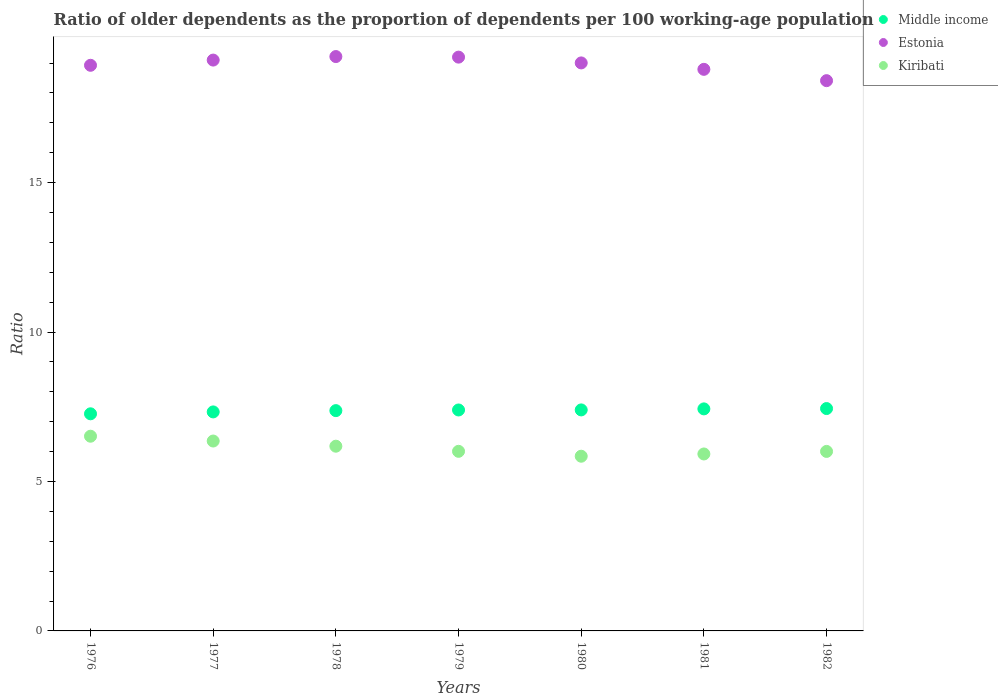What is the age dependency ratio(old) in Middle income in 1982?
Give a very brief answer. 7.44. Across all years, what is the maximum age dependency ratio(old) in Middle income?
Give a very brief answer. 7.44. Across all years, what is the minimum age dependency ratio(old) in Middle income?
Keep it short and to the point. 7.26. In which year was the age dependency ratio(old) in Middle income maximum?
Offer a very short reply. 1982. In which year was the age dependency ratio(old) in Middle income minimum?
Provide a succinct answer. 1976. What is the total age dependency ratio(old) in Estonia in the graph?
Offer a terse response. 132.65. What is the difference between the age dependency ratio(old) in Kiribati in 1978 and that in 1981?
Provide a succinct answer. 0.26. What is the difference between the age dependency ratio(old) in Estonia in 1979 and the age dependency ratio(old) in Kiribati in 1978?
Provide a short and direct response. 13.02. What is the average age dependency ratio(old) in Estonia per year?
Make the answer very short. 18.95. In the year 1978, what is the difference between the age dependency ratio(old) in Estonia and age dependency ratio(old) in Kiribati?
Offer a terse response. 13.04. In how many years, is the age dependency ratio(old) in Estonia greater than 16?
Your answer should be compact. 7. What is the ratio of the age dependency ratio(old) in Kiribati in 1977 to that in 1980?
Keep it short and to the point. 1.09. What is the difference between the highest and the second highest age dependency ratio(old) in Estonia?
Make the answer very short. 0.02. What is the difference between the highest and the lowest age dependency ratio(old) in Estonia?
Your response must be concise. 0.81. Is it the case that in every year, the sum of the age dependency ratio(old) in Estonia and age dependency ratio(old) in Middle income  is greater than the age dependency ratio(old) in Kiribati?
Ensure brevity in your answer.  Yes. Is the age dependency ratio(old) in Kiribati strictly greater than the age dependency ratio(old) in Middle income over the years?
Your answer should be very brief. No. How many dotlines are there?
Make the answer very short. 3. How many years are there in the graph?
Provide a short and direct response. 7. What is the difference between two consecutive major ticks on the Y-axis?
Ensure brevity in your answer.  5. Does the graph contain grids?
Keep it short and to the point. No. Where does the legend appear in the graph?
Your answer should be compact. Top right. How many legend labels are there?
Provide a succinct answer. 3. What is the title of the graph?
Your answer should be very brief. Ratio of older dependents as the proportion of dependents per 100 working-age population. Does "St. Kitts and Nevis" appear as one of the legend labels in the graph?
Offer a very short reply. No. What is the label or title of the Y-axis?
Keep it short and to the point. Ratio. What is the Ratio of Middle income in 1976?
Ensure brevity in your answer.  7.26. What is the Ratio in Estonia in 1976?
Offer a very short reply. 18.93. What is the Ratio of Kiribati in 1976?
Ensure brevity in your answer.  6.51. What is the Ratio in Middle income in 1977?
Make the answer very short. 7.33. What is the Ratio in Estonia in 1977?
Ensure brevity in your answer.  19.1. What is the Ratio of Kiribati in 1977?
Your response must be concise. 6.35. What is the Ratio of Middle income in 1978?
Give a very brief answer. 7.37. What is the Ratio in Estonia in 1978?
Make the answer very short. 19.22. What is the Ratio of Kiribati in 1978?
Make the answer very short. 6.18. What is the Ratio of Middle income in 1979?
Your answer should be compact. 7.39. What is the Ratio of Estonia in 1979?
Your answer should be very brief. 19.2. What is the Ratio in Kiribati in 1979?
Provide a succinct answer. 6.01. What is the Ratio of Middle income in 1980?
Your response must be concise. 7.39. What is the Ratio in Estonia in 1980?
Ensure brevity in your answer.  19. What is the Ratio in Kiribati in 1980?
Your answer should be compact. 5.85. What is the Ratio of Middle income in 1981?
Your answer should be very brief. 7.43. What is the Ratio of Estonia in 1981?
Your answer should be compact. 18.79. What is the Ratio in Kiribati in 1981?
Offer a terse response. 5.92. What is the Ratio of Middle income in 1982?
Give a very brief answer. 7.44. What is the Ratio of Estonia in 1982?
Offer a terse response. 18.41. What is the Ratio of Kiribati in 1982?
Provide a succinct answer. 6.01. Across all years, what is the maximum Ratio in Middle income?
Keep it short and to the point. 7.44. Across all years, what is the maximum Ratio in Estonia?
Your answer should be compact. 19.22. Across all years, what is the maximum Ratio in Kiribati?
Offer a very short reply. 6.51. Across all years, what is the minimum Ratio in Middle income?
Keep it short and to the point. 7.26. Across all years, what is the minimum Ratio of Estonia?
Your answer should be very brief. 18.41. Across all years, what is the minimum Ratio in Kiribati?
Provide a short and direct response. 5.85. What is the total Ratio in Middle income in the graph?
Provide a short and direct response. 51.62. What is the total Ratio of Estonia in the graph?
Provide a short and direct response. 132.65. What is the total Ratio in Kiribati in the graph?
Make the answer very short. 42.83. What is the difference between the Ratio in Middle income in 1976 and that in 1977?
Offer a terse response. -0.06. What is the difference between the Ratio of Estonia in 1976 and that in 1977?
Make the answer very short. -0.17. What is the difference between the Ratio of Kiribati in 1976 and that in 1977?
Provide a short and direct response. 0.16. What is the difference between the Ratio in Middle income in 1976 and that in 1978?
Ensure brevity in your answer.  -0.11. What is the difference between the Ratio in Estonia in 1976 and that in 1978?
Your answer should be very brief. -0.29. What is the difference between the Ratio in Kiribati in 1976 and that in 1978?
Offer a very short reply. 0.33. What is the difference between the Ratio in Middle income in 1976 and that in 1979?
Offer a very short reply. -0.13. What is the difference between the Ratio in Estonia in 1976 and that in 1979?
Your response must be concise. -0.27. What is the difference between the Ratio in Kiribati in 1976 and that in 1979?
Provide a short and direct response. 0.51. What is the difference between the Ratio in Middle income in 1976 and that in 1980?
Your answer should be very brief. -0.13. What is the difference between the Ratio of Estonia in 1976 and that in 1980?
Offer a terse response. -0.08. What is the difference between the Ratio in Kiribati in 1976 and that in 1980?
Your answer should be compact. 0.67. What is the difference between the Ratio in Middle income in 1976 and that in 1981?
Provide a short and direct response. -0.16. What is the difference between the Ratio in Estonia in 1976 and that in 1981?
Ensure brevity in your answer.  0.14. What is the difference between the Ratio of Kiribati in 1976 and that in 1981?
Your answer should be very brief. 0.59. What is the difference between the Ratio in Middle income in 1976 and that in 1982?
Your answer should be compact. -0.18. What is the difference between the Ratio of Estonia in 1976 and that in 1982?
Offer a very short reply. 0.51. What is the difference between the Ratio in Kiribati in 1976 and that in 1982?
Provide a succinct answer. 0.51. What is the difference between the Ratio of Middle income in 1977 and that in 1978?
Keep it short and to the point. -0.04. What is the difference between the Ratio in Estonia in 1977 and that in 1978?
Keep it short and to the point. -0.12. What is the difference between the Ratio in Kiribati in 1977 and that in 1978?
Offer a terse response. 0.17. What is the difference between the Ratio of Middle income in 1977 and that in 1979?
Provide a succinct answer. -0.07. What is the difference between the Ratio in Estonia in 1977 and that in 1979?
Your response must be concise. -0.1. What is the difference between the Ratio in Kiribati in 1977 and that in 1979?
Your answer should be compact. 0.34. What is the difference between the Ratio in Middle income in 1977 and that in 1980?
Give a very brief answer. -0.07. What is the difference between the Ratio in Estonia in 1977 and that in 1980?
Make the answer very short. 0.1. What is the difference between the Ratio of Kiribati in 1977 and that in 1980?
Ensure brevity in your answer.  0.51. What is the difference between the Ratio of Middle income in 1977 and that in 1981?
Your answer should be compact. -0.1. What is the difference between the Ratio in Estonia in 1977 and that in 1981?
Make the answer very short. 0.31. What is the difference between the Ratio of Kiribati in 1977 and that in 1981?
Your response must be concise. 0.43. What is the difference between the Ratio in Middle income in 1977 and that in 1982?
Your answer should be very brief. -0.11. What is the difference between the Ratio in Estonia in 1977 and that in 1982?
Ensure brevity in your answer.  0.69. What is the difference between the Ratio of Kiribati in 1977 and that in 1982?
Keep it short and to the point. 0.35. What is the difference between the Ratio in Middle income in 1978 and that in 1979?
Give a very brief answer. -0.02. What is the difference between the Ratio in Estonia in 1978 and that in 1979?
Offer a terse response. 0.02. What is the difference between the Ratio of Kiribati in 1978 and that in 1979?
Keep it short and to the point. 0.17. What is the difference between the Ratio in Middle income in 1978 and that in 1980?
Keep it short and to the point. -0.02. What is the difference between the Ratio in Estonia in 1978 and that in 1980?
Your response must be concise. 0.21. What is the difference between the Ratio of Kiribati in 1978 and that in 1980?
Your response must be concise. 0.34. What is the difference between the Ratio of Middle income in 1978 and that in 1981?
Offer a terse response. -0.06. What is the difference between the Ratio of Estonia in 1978 and that in 1981?
Provide a succinct answer. 0.43. What is the difference between the Ratio of Kiribati in 1978 and that in 1981?
Give a very brief answer. 0.26. What is the difference between the Ratio of Middle income in 1978 and that in 1982?
Make the answer very short. -0.07. What is the difference between the Ratio of Estonia in 1978 and that in 1982?
Provide a succinct answer. 0.81. What is the difference between the Ratio of Kiribati in 1978 and that in 1982?
Provide a short and direct response. 0.17. What is the difference between the Ratio of Middle income in 1979 and that in 1980?
Ensure brevity in your answer.  -0. What is the difference between the Ratio of Estonia in 1979 and that in 1980?
Keep it short and to the point. 0.19. What is the difference between the Ratio in Kiribati in 1979 and that in 1980?
Your answer should be compact. 0.16. What is the difference between the Ratio in Middle income in 1979 and that in 1981?
Ensure brevity in your answer.  -0.04. What is the difference between the Ratio in Estonia in 1979 and that in 1981?
Give a very brief answer. 0.41. What is the difference between the Ratio in Kiribati in 1979 and that in 1981?
Your response must be concise. 0.09. What is the difference between the Ratio of Middle income in 1979 and that in 1982?
Provide a succinct answer. -0.05. What is the difference between the Ratio in Estonia in 1979 and that in 1982?
Give a very brief answer. 0.79. What is the difference between the Ratio of Kiribati in 1979 and that in 1982?
Give a very brief answer. 0. What is the difference between the Ratio in Middle income in 1980 and that in 1981?
Ensure brevity in your answer.  -0.03. What is the difference between the Ratio of Estonia in 1980 and that in 1981?
Give a very brief answer. 0.21. What is the difference between the Ratio in Kiribati in 1980 and that in 1981?
Your answer should be very brief. -0.08. What is the difference between the Ratio in Middle income in 1980 and that in 1982?
Provide a short and direct response. -0.05. What is the difference between the Ratio in Estonia in 1980 and that in 1982?
Provide a succinct answer. 0.59. What is the difference between the Ratio of Kiribati in 1980 and that in 1982?
Make the answer very short. -0.16. What is the difference between the Ratio of Middle income in 1981 and that in 1982?
Offer a terse response. -0.01. What is the difference between the Ratio in Estonia in 1981 and that in 1982?
Provide a succinct answer. 0.38. What is the difference between the Ratio of Kiribati in 1981 and that in 1982?
Your response must be concise. -0.09. What is the difference between the Ratio of Middle income in 1976 and the Ratio of Estonia in 1977?
Make the answer very short. -11.84. What is the difference between the Ratio of Middle income in 1976 and the Ratio of Kiribati in 1977?
Provide a succinct answer. 0.91. What is the difference between the Ratio in Estonia in 1976 and the Ratio in Kiribati in 1977?
Provide a succinct answer. 12.57. What is the difference between the Ratio of Middle income in 1976 and the Ratio of Estonia in 1978?
Offer a very short reply. -11.95. What is the difference between the Ratio of Middle income in 1976 and the Ratio of Kiribati in 1978?
Offer a terse response. 1.08. What is the difference between the Ratio of Estonia in 1976 and the Ratio of Kiribati in 1978?
Give a very brief answer. 12.74. What is the difference between the Ratio of Middle income in 1976 and the Ratio of Estonia in 1979?
Provide a succinct answer. -11.93. What is the difference between the Ratio in Middle income in 1976 and the Ratio in Kiribati in 1979?
Provide a short and direct response. 1.26. What is the difference between the Ratio of Estonia in 1976 and the Ratio of Kiribati in 1979?
Provide a succinct answer. 12.92. What is the difference between the Ratio in Middle income in 1976 and the Ratio in Estonia in 1980?
Provide a succinct answer. -11.74. What is the difference between the Ratio of Middle income in 1976 and the Ratio of Kiribati in 1980?
Offer a very short reply. 1.42. What is the difference between the Ratio in Estonia in 1976 and the Ratio in Kiribati in 1980?
Ensure brevity in your answer.  13.08. What is the difference between the Ratio in Middle income in 1976 and the Ratio in Estonia in 1981?
Make the answer very short. -11.53. What is the difference between the Ratio in Middle income in 1976 and the Ratio in Kiribati in 1981?
Provide a succinct answer. 1.34. What is the difference between the Ratio of Estonia in 1976 and the Ratio of Kiribati in 1981?
Give a very brief answer. 13. What is the difference between the Ratio in Middle income in 1976 and the Ratio in Estonia in 1982?
Give a very brief answer. -11.15. What is the difference between the Ratio in Middle income in 1976 and the Ratio in Kiribati in 1982?
Your answer should be very brief. 1.26. What is the difference between the Ratio in Estonia in 1976 and the Ratio in Kiribati in 1982?
Keep it short and to the point. 12.92. What is the difference between the Ratio in Middle income in 1977 and the Ratio in Estonia in 1978?
Offer a terse response. -11.89. What is the difference between the Ratio of Middle income in 1977 and the Ratio of Kiribati in 1978?
Your answer should be very brief. 1.15. What is the difference between the Ratio in Estonia in 1977 and the Ratio in Kiribati in 1978?
Offer a very short reply. 12.92. What is the difference between the Ratio in Middle income in 1977 and the Ratio in Estonia in 1979?
Make the answer very short. -11.87. What is the difference between the Ratio of Middle income in 1977 and the Ratio of Kiribati in 1979?
Keep it short and to the point. 1.32. What is the difference between the Ratio of Estonia in 1977 and the Ratio of Kiribati in 1979?
Make the answer very short. 13.09. What is the difference between the Ratio in Middle income in 1977 and the Ratio in Estonia in 1980?
Give a very brief answer. -11.68. What is the difference between the Ratio of Middle income in 1977 and the Ratio of Kiribati in 1980?
Offer a very short reply. 1.48. What is the difference between the Ratio of Estonia in 1977 and the Ratio of Kiribati in 1980?
Offer a terse response. 13.25. What is the difference between the Ratio in Middle income in 1977 and the Ratio in Estonia in 1981?
Keep it short and to the point. -11.46. What is the difference between the Ratio of Middle income in 1977 and the Ratio of Kiribati in 1981?
Your response must be concise. 1.41. What is the difference between the Ratio in Estonia in 1977 and the Ratio in Kiribati in 1981?
Your answer should be very brief. 13.18. What is the difference between the Ratio in Middle income in 1977 and the Ratio in Estonia in 1982?
Ensure brevity in your answer.  -11.08. What is the difference between the Ratio of Middle income in 1977 and the Ratio of Kiribati in 1982?
Give a very brief answer. 1.32. What is the difference between the Ratio of Estonia in 1977 and the Ratio of Kiribati in 1982?
Offer a very short reply. 13.09. What is the difference between the Ratio of Middle income in 1978 and the Ratio of Estonia in 1979?
Offer a terse response. -11.83. What is the difference between the Ratio in Middle income in 1978 and the Ratio in Kiribati in 1979?
Provide a short and direct response. 1.36. What is the difference between the Ratio of Estonia in 1978 and the Ratio of Kiribati in 1979?
Provide a succinct answer. 13.21. What is the difference between the Ratio of Middle income in 1978 and the Ratio of Estonia in 1980?
Keep it short and to the point. -11.63. What is the difference between the Ratio in Middle income in 1978 and the Ratio in Kiribati in 1980?
Your answer should be compact. 1.53. What is the difference between the Ratio of Estonia in 1978 and the Ratio of Kiribati in 1980?
Offer a terse response. 13.37. What is the difference between the Ratio in Middle income in 1978 and the Ratio in Estonia in 1981?
Your answer should be compact. -11.42. What is the difference between the Ratio of Middle income in 1978 and the Ratio of Kiribati in 1981?
Your answer should be compact. 1.45. What is the difference between the Ratio in Estonia in 1978 and the Ratio in Kiribati in 1981?
Ensure brevity in your answer.  13.3. What is the difference between the Ratio of Middle income in 1978 and the Ratio of Estonia in 1982?
Give a very brief answer. -11.04. What is the difference between the Ratio of Middle income in 1978 and the Ratio of Kiribati in 1982?
Your answer should be compact. 1.36. What is the difference between the Ratio in Estonia in 1978 and the Ratio in Kiribati in 1982?
Your answer should be very brief. 13.21. What is the difference between the Ratio in Middle income in 1979 and the Ratio in Estonia in 1980?
Your response must be concise. -11.61. What is the difference between the Ratio of Middle income in 1979 and the Ratio of Kiribati in 1980?
Your answer should be compact. 1.55. What is the difference between the Ratio of Estonia in 1979 and the Ratio of Kiribati in 1980?
Provide a short and direct response. 13.35. What is the difference between the Ratio in Middle income in 1979 and the Ratio in Estonia in 1981?
Your response must be concise. -11.4. What is the difference between the Ratio of Middle income in 1979 and the Ratio of Kiribati in 1981?
Keep it short and to the point. 1.47. What is the difference between the Ratio of Estonia in 1979 and the Ratio of Kiribati in 1981?
Offer a terse response. 13.28. What is the difference between the Ratio of Middle income in 1979 and the Ratio of Estonia in 1982?
Offer a very short reply. -11.02. What is the difference between the Ratio in Middle income in 1979 and the Ratio in Kiribati in 1982?
Provide a succinct answer. 1.39. What is the difference between the Ratio in Estonia in 1979 and the Ratio in Kiribati in 1982?
Offer a very short reply. 13.19. What is the difference between the Ratio of Middle income in 1980 and the Ratio of Estonia in 1981?
Provide a succinct answer. -11.4. What is the difference between the Ratio of Middle income in 1980 and the Ratio of Kiribati in 1981?
Offer a terse response. 1.47. What is the difference between the Ratio of Estonia in 1980 and the Ratio of Kiribati in 1981?
Offer a terse response. 13.08. What is the difference between the Ratio in Middle income in 1980 and the Ratio in Estonia in 1982?
Keep it short and to the point. -11.02. What is the difference between the Ratio in Middle income in 1980 and the Ratio in Kiribati in 1982?
Keep it short and to the point. 1.39. What is the difference between the Ratio in Estonia in 1980 and the Ratio in Kiribati in 1982?
Your answer should be compact. 13. What is the difference between the Ratio of Middle income in 1981 and the Ratio of Estonia in 1982?
Provide a succinct answer. -10.98. What is the difference between the Ratio of Middle income in 1981 and the Ratio of Kiribati in 1982?
Provide a succinct answer. 1.42. What is the difference between the Ratio of Estonia in 1981 and the Ratio of Kiribati in 1982?
Your response must be concise. 12.78. What is the average Ratio in Middle income per year?
Offer a terse response. 7.37. What is the average Ratio of Estonia per year?
Make the answer very short. 18.95. What is the average Ratio in Kiribati per year?
Offer a terse response. 6.12. In the year 1976, what is the difference between the Ratio of Middle income and Ratio of Estonia?
Make the answer very short. -11.66. In the year 1976, what is the difference between the Ratio of Middle income and Ratio of Kiribati?
Give a very brief answer. 0.75. In the year 1976, what is the difference between the Ratio in Estonia and Ratio in Kiribati?
Give a very brief answer. 12.41. In the year 1977, what is the difference between the Ratio in Middle income and Ratio in Estonia?
Offer a very short reply. -11.77. In the year 1977, what is the difference between the Ratio of Middle income and Ratio of Kiribati?
Your answer should be compact. 0.97. In the year 1977, what is the difference between the Ratio in Estonia and Ratio in Kiribati?
Your answer should be very brief. 12.75. In the year 1978, what is the difference between the Ratio in Middle income and Ratio in Estonia?
Keep it short and to the point. -11.85. In the year 1978, what is the difference between the Ratio of Middle income and Ratio of Kiribati?
Your response must be concise. 1.19. In the year 1978, what is the difference between the Ratio in Estonia and Ratio in Kiribati?
Your answer should be compact. 13.04. In the year 1979, what is the difference between the Ratio of Middle income and Ratio of Estonia?
Keep it short and to the point. -11.81. In the year 1979, what is the difference between the Ratio in Middle income and Ratio in Kiribati?
Keep it short and to the point. 1.38. In the year 1979, what is the difference between the Ratio in Estonia and Ratio in Kiribati?
Your response must be concise. 13.19. In the year 1980, what is the difference between the Ratio in Middle income and Ratio in Estonia?
Make the answer very short. -11.61. In the year 1980, what is the difference between the Ratio of Middle income and Ratio of Kiribati?
Provide a short and direct response. 1.55. In the year 1980, what is the difference between the Ratio in Estonia and Ratio in Kiribati?
Give a very brief answer. 13.16. In the year 1981, what is the difference between the Ratio of Middle income and Ratio of Estonia?
Make the answer very short. -11.36. In the year 1981, what is the difference between the Ratio of Middle income and Ratio of Kiribati?
Your answer should be compact. 1.51. In the year 1981, what is the difference between the Ratio in Estonia and Ratio in Kiribati?
Provide a succinct answer. 12.87. In the year 1982, what is the difference between the Ratio of Middle income and Ratio of Estonia?
Give a very brief answer. -10.97. In the year 1982, what is the difference between the Ratio in Middle income and Ratio in Kiribati?
Your answer should be compact. 1.43. In the year 1982, what is the difference between the Ratio in Estonia and Ratio in Kiribati?
Make the answer very short. 12.41. What is the ratio of the Ratio in Estonia in 1976 to that in 1977?
Provide a short and direct response. 0.99. What is the ratio of the Ratio in Kiribati in 1976 to that in 1977?
Offer a very short reply. 1.03. What is the ratio of the Ratio in Middle income in 1976 to that in 1978?
Give a very brief answer. 0.99. What is the ratio of the Ratio in Kiribati in 1976 to that in 1978?
Your answer should be compact. 1.05. What is the ratio of the Ratio of Middle income in 1976 to that in 1979?
Your response must be concise. 0.98. What is the ratio of the Ratio in Estonia in 1976 to that in 1979?
Offer a very short reply. 0.99. What is the ratio of the Ratio of Kiribati in 1976 to that in 1979?
Give a very brief answer. 1.08. What is the ratio of the Ratio of Middle income in 1976 to that in 1980?
Keep it short and to the point. 0.98. What is the ratio of the Ratio in Kiribati in 1976 to that in 1980?
Give a very brief answer. 1.11. What is the ratio of the Ratio of Middle income in 1976 to that in 1981?
Offer a terse response. 0.98. What is the ratio of the Ratio in Kiribati in 1976 to that in 1981?
Provide a short and direct response. 1.1. What is the ratio of the Ratio in Middle income in 1976 to that in 1982?
Keep it short and to the point. 0.98. What is the ratio of the Ratio in Estonia in 1976 to that in 1982?
Offer a very short reply. 1.03. What is the ratio of the Ratio of Kiribati in 1976 to that in 1982?
Ensure brevity in your answer.  1.08. What is the ratio of the Ratio in Middle income in 1977 to that in 1978?
Your response must be concise. 0.99. What is the ratio of the Ratio in Kiribati in 1977 to that in 1978?
Your answer should be very brief. 1.03. What is the ratio of the Ratio in Kiribati in 1977 to that in 1979?
Your answer should be very brief. 1.06. What is the ratio of the Ratio of Middle income in 1977 to that in 1980?
Ensure brevity in your answer.  0.99. What is the ratio of the Ratio in Estonia in 1977 to that in 1980?
Give a very brief answer. 1. What is the ratio of the Ratio in Kiribati in 1977 to that in 1980?
Your answer should be very brief. 1.09. What is the ratio of the Ratio of Middle income in 1977 to that in 1981?
Give a very brief answer. 0.99. What is the ratio of the Ratio in Estonia in 1977 to that in 1981?
Offer a terse response. 1.02. What is the ratio of the Ratio in Kiribati in 1977 to that in 1981?
Your answer should be very brief. 1.07. What is the ratio of the Ratio in Middle income in 1977 to that in 1982?
Ensure brevity in your answer.  0.98. What is the ratio of the Ratio in Estonia in 1977 to that in 1982?
Offer a very short reply. 1.04. What is the ratio of the Ratio in Kiribati in 1977 to that in 1982?
Ensure brevity in your answer.  1.06. What is the ratio of the Ratio in Kiribati in 1978 to that in 1979?
Make the answer very short. 1.03. What is the ratio of the Ratio in Estonia in 1978 to that in 1980?
Give a very brief answer. 1.01. What is the ratio of the Ratio in Kiribati in 1978 to that in 1980?
Your response must be concise. 1.06. What is the ratio of the Ratio in Estonia in 1978 to that in 1981?
Your answer should be compact. 1.02. What is the ratio of the Ratio in Kiribati in 1978 to that in 1981?
Give a very brief answer. 1.04. What is the ratio of the Ratio in Estonia in 1978 to that in 1982?
Your response must be concise. 1.04. What is the ratio of the Ratio in Kiribati in 1978 to that in 1982?
Make the answer very short. 1.03. What is the ratio of the Ratio in Estonia in 1979 to that in 1980?
Provide a succinct answer. 1.01. What is the ratio of the Ratio in Kiribati in 1979 to that in 1980?
Offer a terse response. 1.03. What is the ratio of the Ratio of Middle income in 1979 to that in 1981?
Your answer should be very brief. 1. What is the ratio of the Ratio of Estonia in 1979 to that in 1981?
Offer a very short reply. 1.02. What is the ratio of the Ratio of Middle income in 1979 to that in 1982?
Provide a succinct answer. 0.99. What is the ratio of the Ratio of Estonia in 1979 to that in 1982?
Give a very brief answer. 1.04. What is the ratio of the Ratio of Estonia in 1980 to that in 1981?
Offer a terse response. 1.01. What is the ratio of the Ratio in Kiribati in 1980 to that in 1981?
Keep it short and to the point. 0.99. What is the ratio of the Ratio in Estonia in 1980 to that in 1982?
Your answer should be compact. 1.03. What is the ratio of the Ratio in Kiribati in 1980 to that in 1982?
Your answer should be compact. 0.97. What is the ratio of the Ratio of Middle income in 1981 to that in 1982?
Provide a short and direct response. 1. What is the ratio of the Ratio in Estonia in 1981 to that in 1982?
Keep it short and to the point. 1.02. What is the ratio of the Ratio in Kiribati in 1981 to that in 1982?
Your answer should be very brief. 0.99. What is the difference between the highest and the second highest Ratio of Middle income?
Make the answer very short. 0.01. What is the difference between the highest and the second highest Ratio of Estonia?
Make the answer very short. 0.02. What is the difference between the highest and the second highest Ratio in Kiribati?
Keep it short and to the point. 0.16. What is the difference between the highest and the lowest Ratio of Middle income?
Offer a very short reply. 0.18. What is the difference between the highest and the lowest Ratio of Estonia?
Provide a succinct answer. 0.81. What is the difference between the highest and the lowest Ratio in Kiribati?
Offer a very short reply. 0.67. 